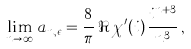Convert formula to latex. <formula><loc_0><loc_0><loc_500><loc_500>\lim _ { n \rightarrow \infty } \, a _ { n , \epsilon } = \frac { 8 } { \pi } \, \Re \, \chi ^ { \prime } ( i ) \, \frac { i ^ { n + 3 } } { n ^ { 3 } } \, ,</formula> 